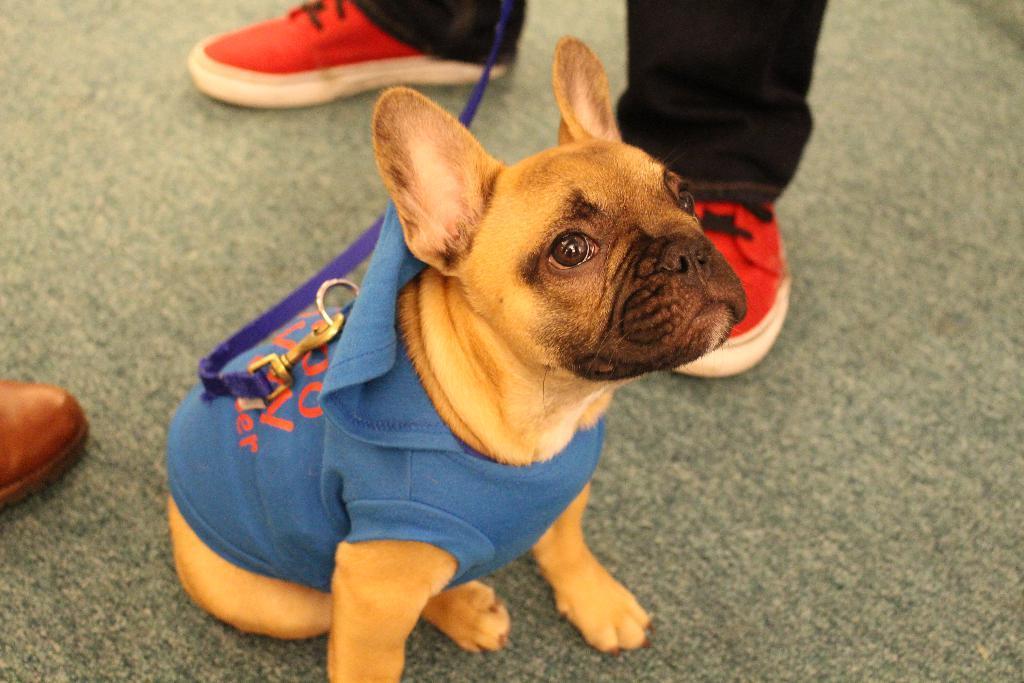Please provide a concise description of this image. In this image we can see a dog with a belt and a dress. Also we can see legs of persons. On the left side we can see part of a shoe. 